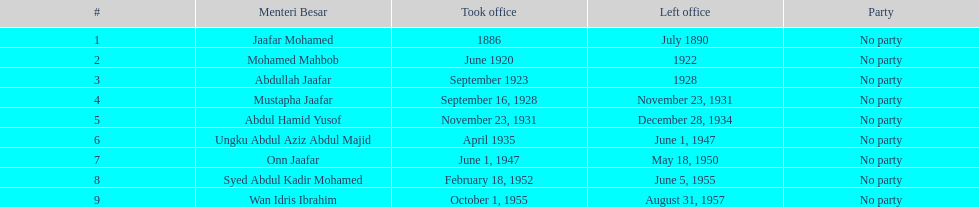What was the duration of ungku abdul aziz abdul majid's tenure? 12 years. 